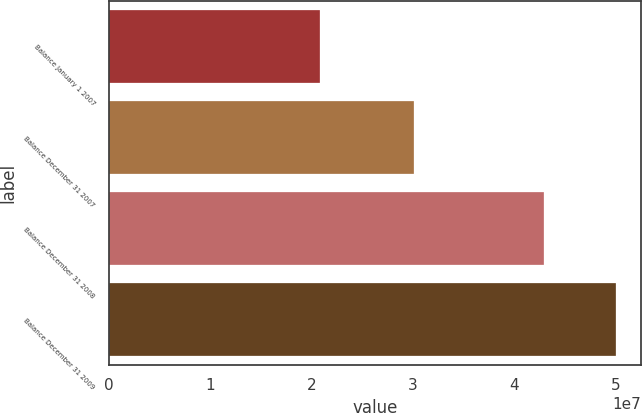<chart> <loc_0><loc_0><loc_500><loc_500><bar_chart><fcel>Balance January 1 2007<fcel>Balance December 31 2007<fcel>Balance December 31 2008<fcel>Balance December 31 2009<nl><fcel>2.08457e+07<fcel>3.00741e+07<fcel>4.29856e+07<fcel>5.00059e+07<nl></chart> 